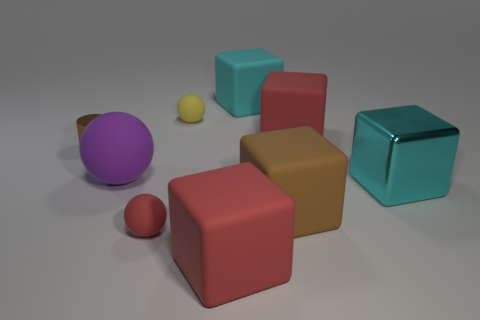What number of other things are the same material as the small brown cylinder?
Keep it short and to the point. 1. What is the material of the tiny yellow sphere?
Provide a succinct answer. Rubber. What number of large objects are either purple rubber things or red rubber cubes?
Give a very brief answer. 3. How many purple matte objects are left of the cyan matte block?
Offer a terse response. 1. Is there a small rubber ball of the same color as the tiny cylinder?
Provide a short and direct response. No. What shape is the red rubber thing that is the same size as the cylinder?
Your answer should be very brief. Sphere. What number of blue things are either large matte balls or large shiny spheres?
Offer a very short reply. 0. What number of other cyan blocks are the same size as the cyan metallic cube?
Provide a short and direct response. 1. How many objects are either small green things or large cyan blocks behind the big shiny object?
Make the answer very short. 1. Is the size of the cyan object behind the large matte sphere the same as the red rubber object that is behind the tiny red object?
Offer a very short reply. Yes. 